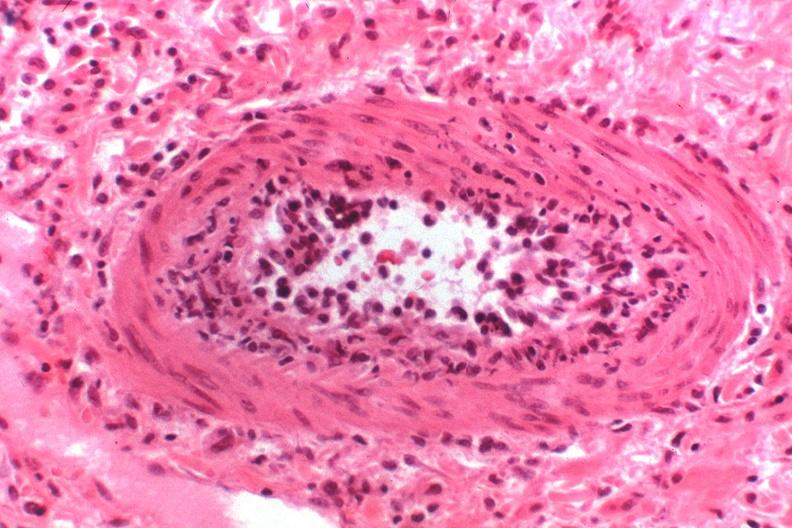does this image show kidney transplant rejection?
Answer the question using a single word or phrase. Yes 